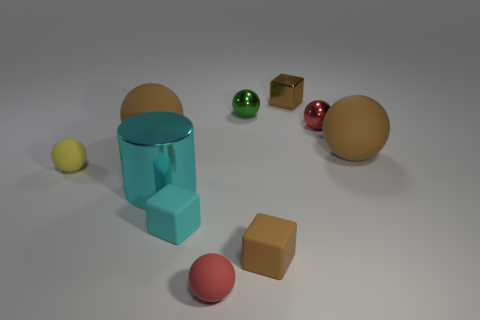Subtract 5 spheres. How many spheres are left? 1 Subtract all small shiny balls. How many balls are left? 4 Subtract all cubes. How many objects are left? 7 Subtract all yellow spheres. How many spheres are left? 5 Subtract all brown cubes. How many green spheres are left? 1 Subtract all big shiny cylinders. Subtract all brown rubber things. How many objects are left? 6 Add 3 big metallic objects. How many big metallic objects are left? 4 Add 4 large red matte cylinders. How many large red matte cylinders exist? 4 Subtract 0 red cylinders. How many objects are left? 10 Subtract all blue cubes. Subtract all gray cylinders. How many cubes are left? 3 